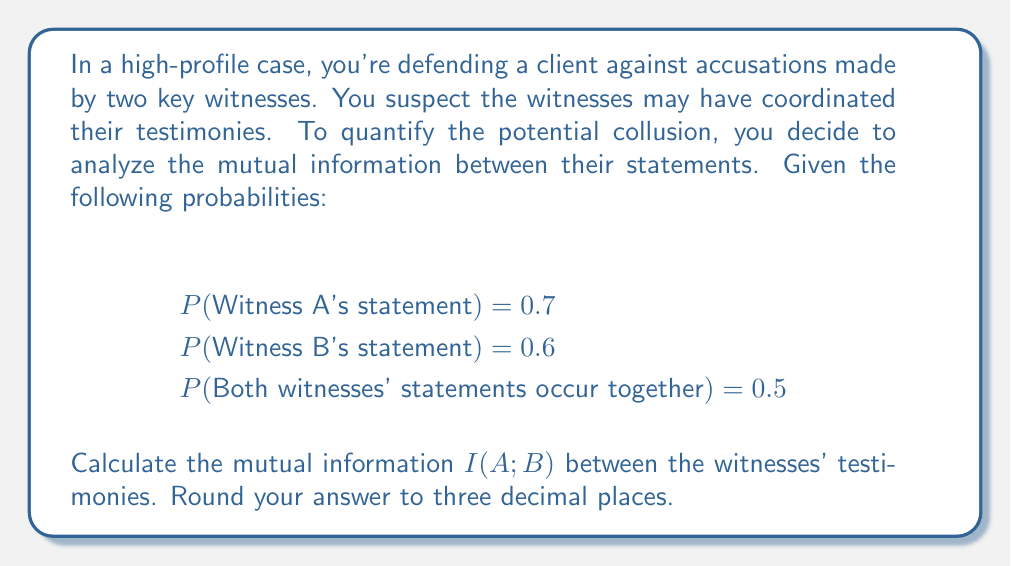What is the answer to this math problem? To calculate the mutual information between the two witnesses' testimonies, we'll use the formula:

$$ I(A;B) = H(A) + H(B) - H(A,B) $$

Where H(A) and H(B) are the individual entropies, and H(A,B) is the joint entropy.

Step 1: Calculate individual entropies

For Witness A:
$$ H(A) = -P(A) \log_2 P(A) - P(\overline{A}) \log_2 P(\overline{A}) $$
$$ H(A) = -0.7 \log_2 0.7 - 0.3 \log_2 0.3 = 0.8813 \text{ bits} $$

For Witness B:
$$ H(B) = -P(B) \log_2 P(B) - P(\overline{B}) \log_2 P(\overline{B}) $$
$$ H(B) = -0.6 \log_2 0.6 - 0.4 \log_2 0.4 = 0.9710 \text{ bits} $$

Step 2: Calculate joint entropy

To calculate H(A,B), we need the joint probability distribution:

P(A=1, B=1) = 0.5
P(A=1, B=0) = 0.2
P(A=0, B=1) = 0.1
P(A=0, B=0) = 0.2

$$ H(A,B) = -\sum_{a,b} P(a,b) \log_2 P(a,b) $$
$$ H(A,B) = -0.5 \log_2 0.5 - 0.2 \log_2 0.2 - 0.1 \log_2 0.1 - 0.2 \log_2 0.2 $$
$$ H(A,B) = 1.7610 \text{ bits} $$

Step 3: Calculate mutual information

$$ I(A;B) = H(A) + H(B) - H(A,B) $$
$$ I(A;B) = 0.8813 + 0.9710 - 1.7610 = 0.0913 \text{ bits} $$

Rounding to three decimal places: 0.091 bits
Answer: 0.091 bits 